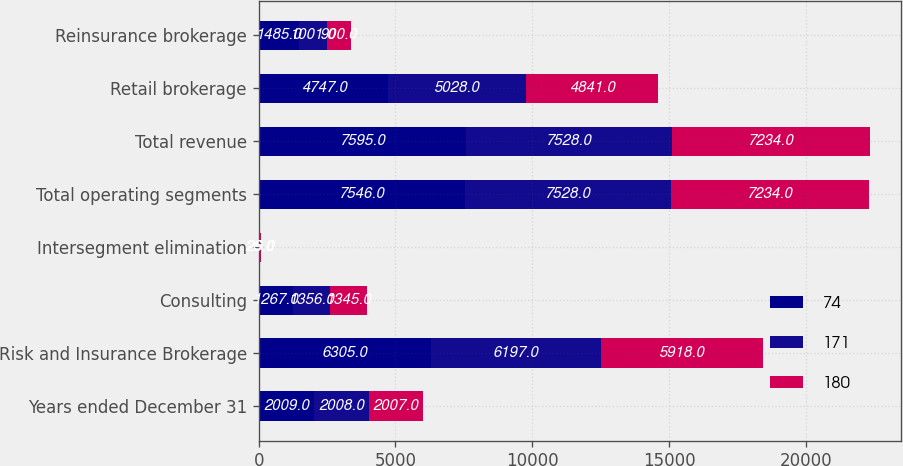Convert chart. <chart><loc_0><loc_0><loc_500><loc_500><stacked_bar_chart><ecel><fcel>Years ended December 31<fcel>Risk and Insurance Brokerage<fcel>Consulting<fcel>Intersegment elimination<fcel>Total operating segments<fcel>Total revenue<fcel>Retail brokerage<fcel>Reinsurance brokerage<nl><fcel>74<fcel>2009<fcel>6305<fcel>1267<fcel>26<fcel>7546<fcel>7595<fcel>4747<fcel>1485<nl><fcel>171<fcel>2008<fcel>6197<fcel>1356<fcel>25<fcel>7528<fcel>7528<fcel>5028<fcel>1001<nl><fcel>180<fcel>2007<fcel>5918<fcel>1345<fcel>29<fcel>7234<fcel>7234<fcel>4841<fcel>900<nl></chart> 